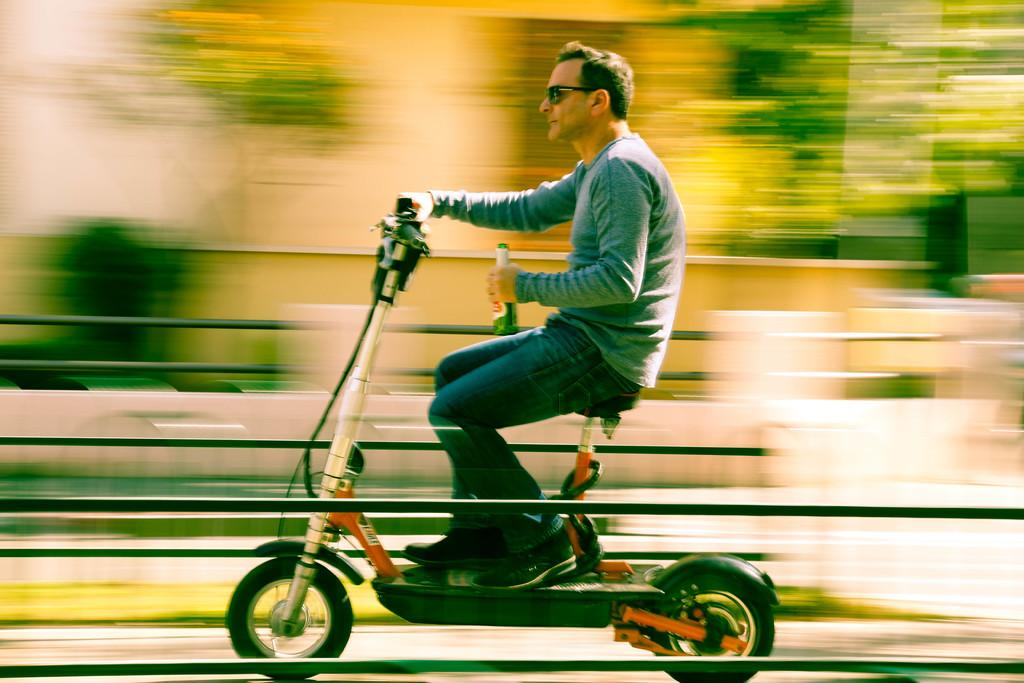Who is the main subject in the image? There is a man in the image. What is the man doing in the image? The man is riding a vehicle on the road. What object is the man holding in his hands? The man is holding a glass bottle in his hands. What type of mitten is the man wearing while riding the vehicle? There is no mitten present in the image; the man is not wearing any gloves or mittens. What type of ship can be seen in the background of the image? There is no ship present in the image; it only shows a man riding a vehicle on the road. 